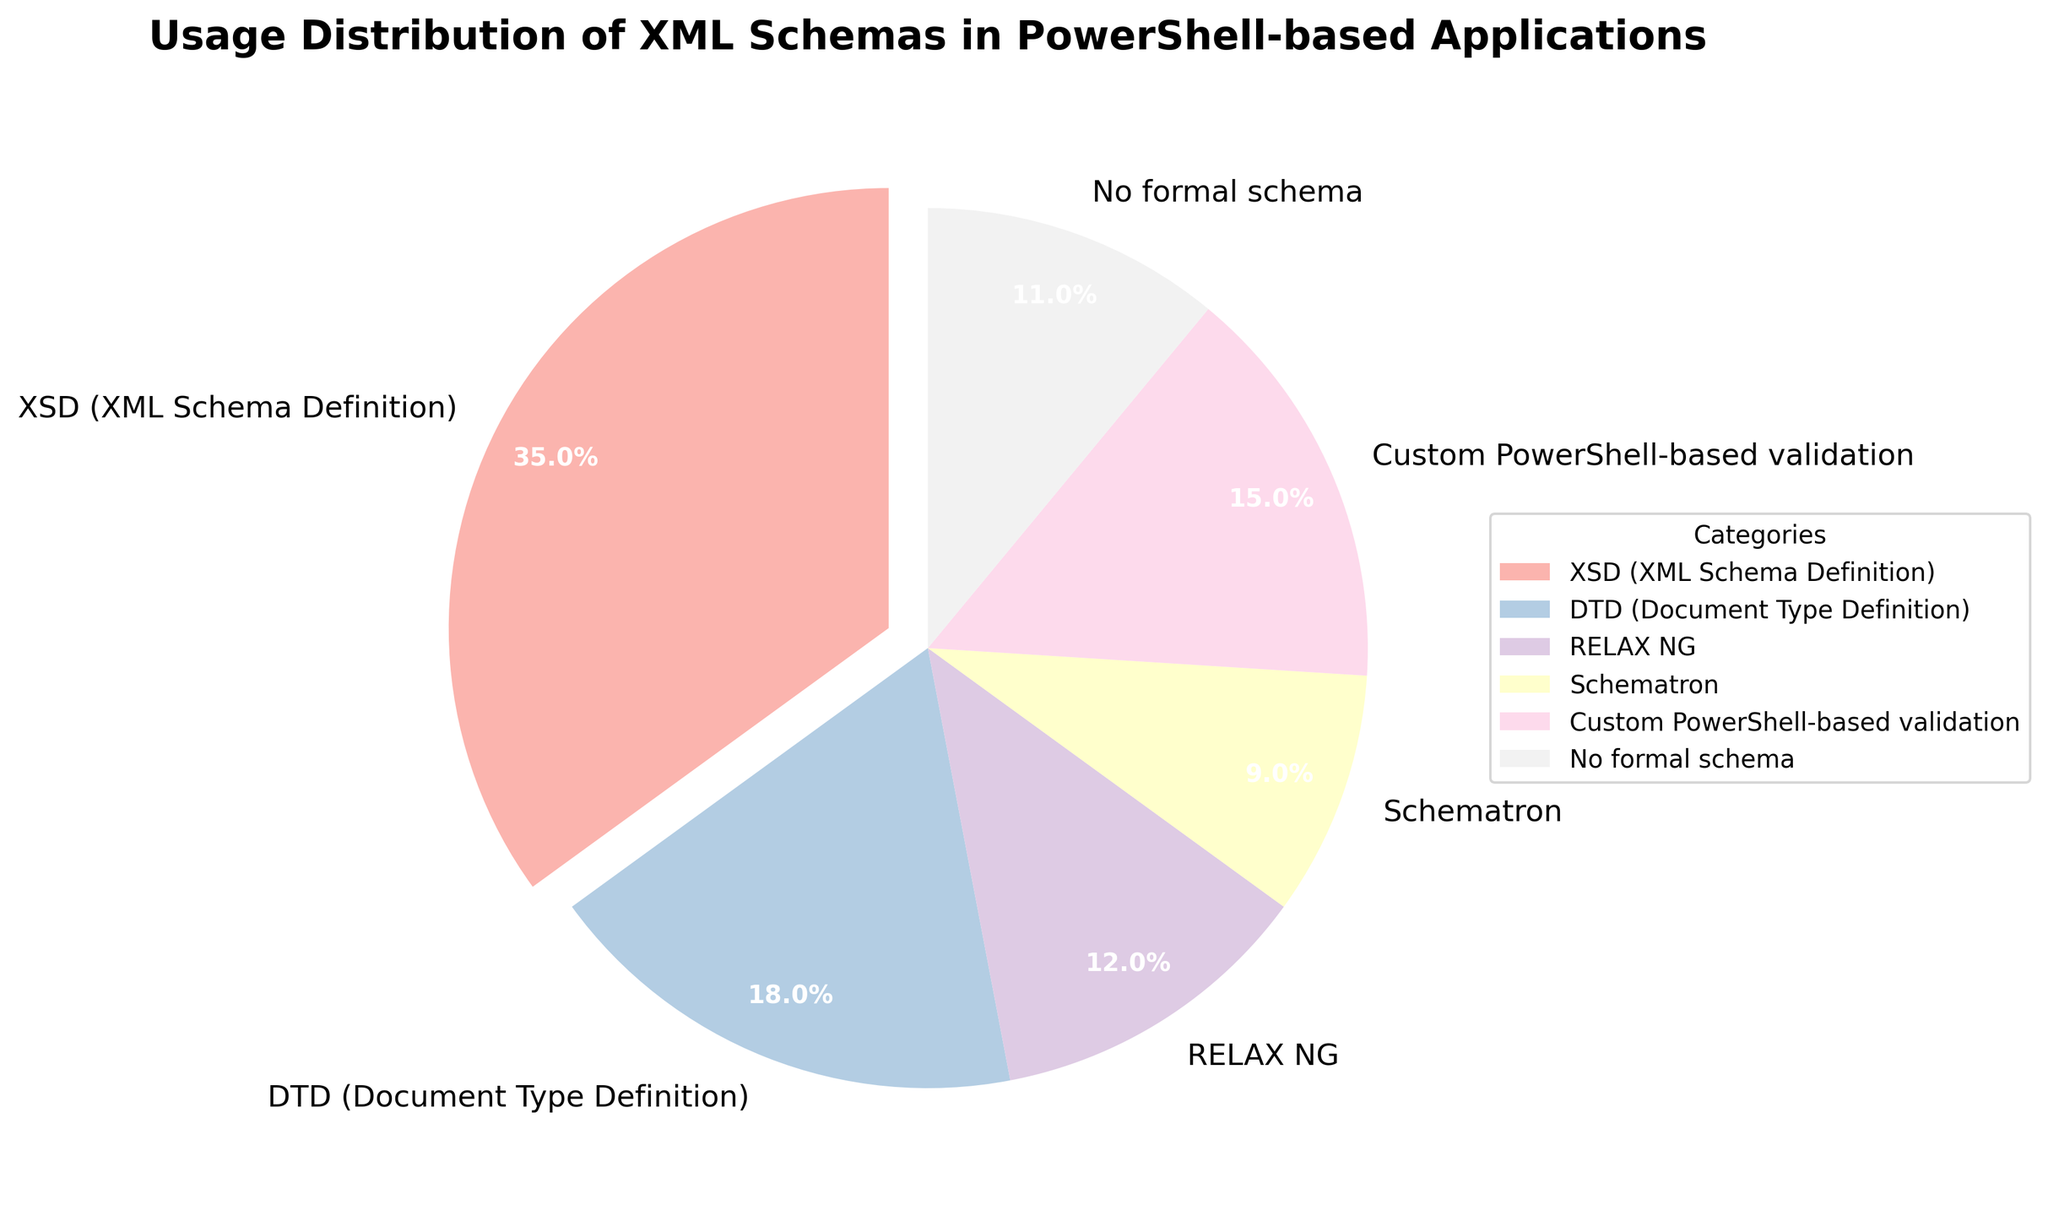What's the most used type of XML schema? The pie chart shows the usage distribution, and the category with the highest percentage is XSD (XML Schema Definition).
Answer: XSD (XML Schema Definition) Which XML schema has the second highest usage? By looking at the pie chart, the category with the next highest percentage after XSD (35%) is DTD (18%).
Answer: DTD (Document Type Definition) What is the total percentage for XSD and Custom PowerShell-based validation combined? The percentage for XSD is 35%, and for Custom PowerShell-based validation is 15%. Adding these together: 35% + 15% = 50%.
Answer: 50% How much larger is the usage of XSD compared to Schematron? The usage of XSD is 35%, and the usage of Schematron is 9%. The difference is 35% - 9% = 26%.
Answer: 26% Which XML schema has the smallest usage? Observing the pie chart, the category with the smallest percentage is Schematron with 9%.
Answer: Schematron What percentage of applications use either RELAX NG or no formal schema? The percentage of applications using RELAX NG is 12%, and those using no formal schema is 11%. Adding these together: 12% + 11% = 23%.
Answer: 23% What is the difference in usage between Custom PowerShell-based validation and DTD? The usage of Custom PowerShell-based validation is 15%, and DTD is 18%. The difference is 18% - 15% = 3%.
Answer: 3% What is the average percentage usage of all categories combined? Summing up all percentages (35 + 18 + 12 + 9 + 15 + 11 = 100) and dividing by the number of categories (6), the average is 100 / 6 = 16.67%.
Answer: 16.67% What color is used to represent the category with the highest percentage? The pie chart legend indicates the color assignments, and the category with the highest percentage, XSD, is represented with a pastel color from the Pastel1 color map.
Answer: Pastel color How does the usage of no formal schema compare to RELAX NG? The usage of no formal schema is 11%, while RELAX NG is 12%. So, no formal schema usage is slightly less than that of RELAX NG by 1%.
Answer: Slightly less 